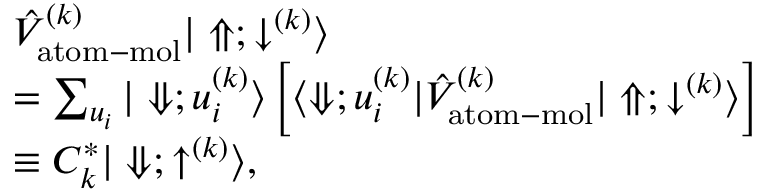<formula> <loc_0><loc_0><loc_500><loc_500>\begin{array} { r l } & { \hat { V } _ { a t o m - m o l } ^ { ( k ) } | \Uparrow ; \downarrow ^ { ( k ) } \rangle } \\ & { = \sum _ { u _ { i } } | \Downarrow ; u _ { i } ^ { ( k ) } \rangle \left [ \langle \Downarrow ; u _ { i } ^ { ( k ) } | \hat { V } _ { a t o m - m o l } ^ { ( k ) } | \Uparrow ; \downarrow ^ { ( k ) } \rangle \right ] } \\ & { \equiv C _ { k } ^ { * } | \Downarrow ; \uparrow ^ { ( k ) } \rangle , } \end{array}</formula> 